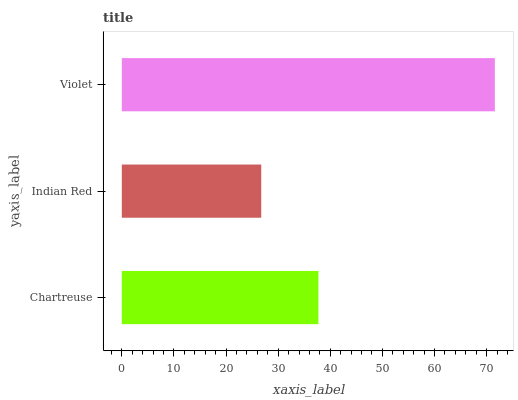Is Indian Red the minimum?
Answer yes or no. Yes. Is Violet the maximum?
Answer yes or no. Yes. Is Violet the minimum?
Answer yes or no. No. Is Indian Red the maximum?
Answer yes or no. No. Is Violet greater than Indian Red?
Answer yes or no. Yes. Is Indian Red less than Violet?
Answer yes or no. Yes. Is Indian Red greater than Violet?
Answer yes or no. No. Is Violet less than Indian Red?
Answer yes or no. No. Is Chartreuse the high median?
Answer yes or no. Yes. Is Chartreuse the low median?
Answer yes or no. Yes. Is Violet the high median?
Answer yes or no. No. Is Violet the low median?
Answer yes or no. No. 